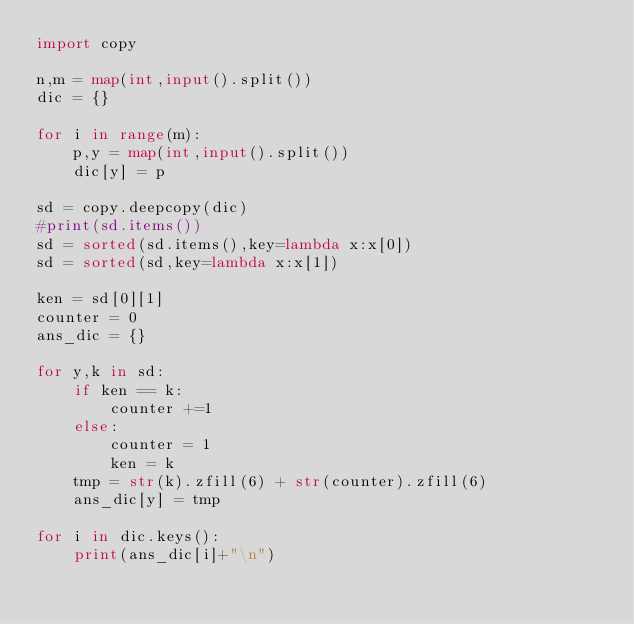<code> <loc_0><loc_0><loc_500><loc_500><_Python_>import copy

n,m = map(int,input().split())
dic = {}

for i in range(m):
    p,y = map(int,input().split())
    dic[y] = p

sd = copy.deepcopy(dic)
#print(sd.items())
sd = sorted(sd.items(),key=lambda x:x[0])
sd = sorted(sd,key=lambda x:x[1])

ken = sd[0][1]
counter = 0
ans_dic = {}

for y,k in sd:
    if ken == k:
        counter +=1
    else:
        counter = 1
        ken = k
    tmp = str(k).zfill(6) + str(counter).zfill(6)
    ans_dic[y] = tmp

for i in dic.keys():
    print(ans_dic[i]+"\n")
</code> 